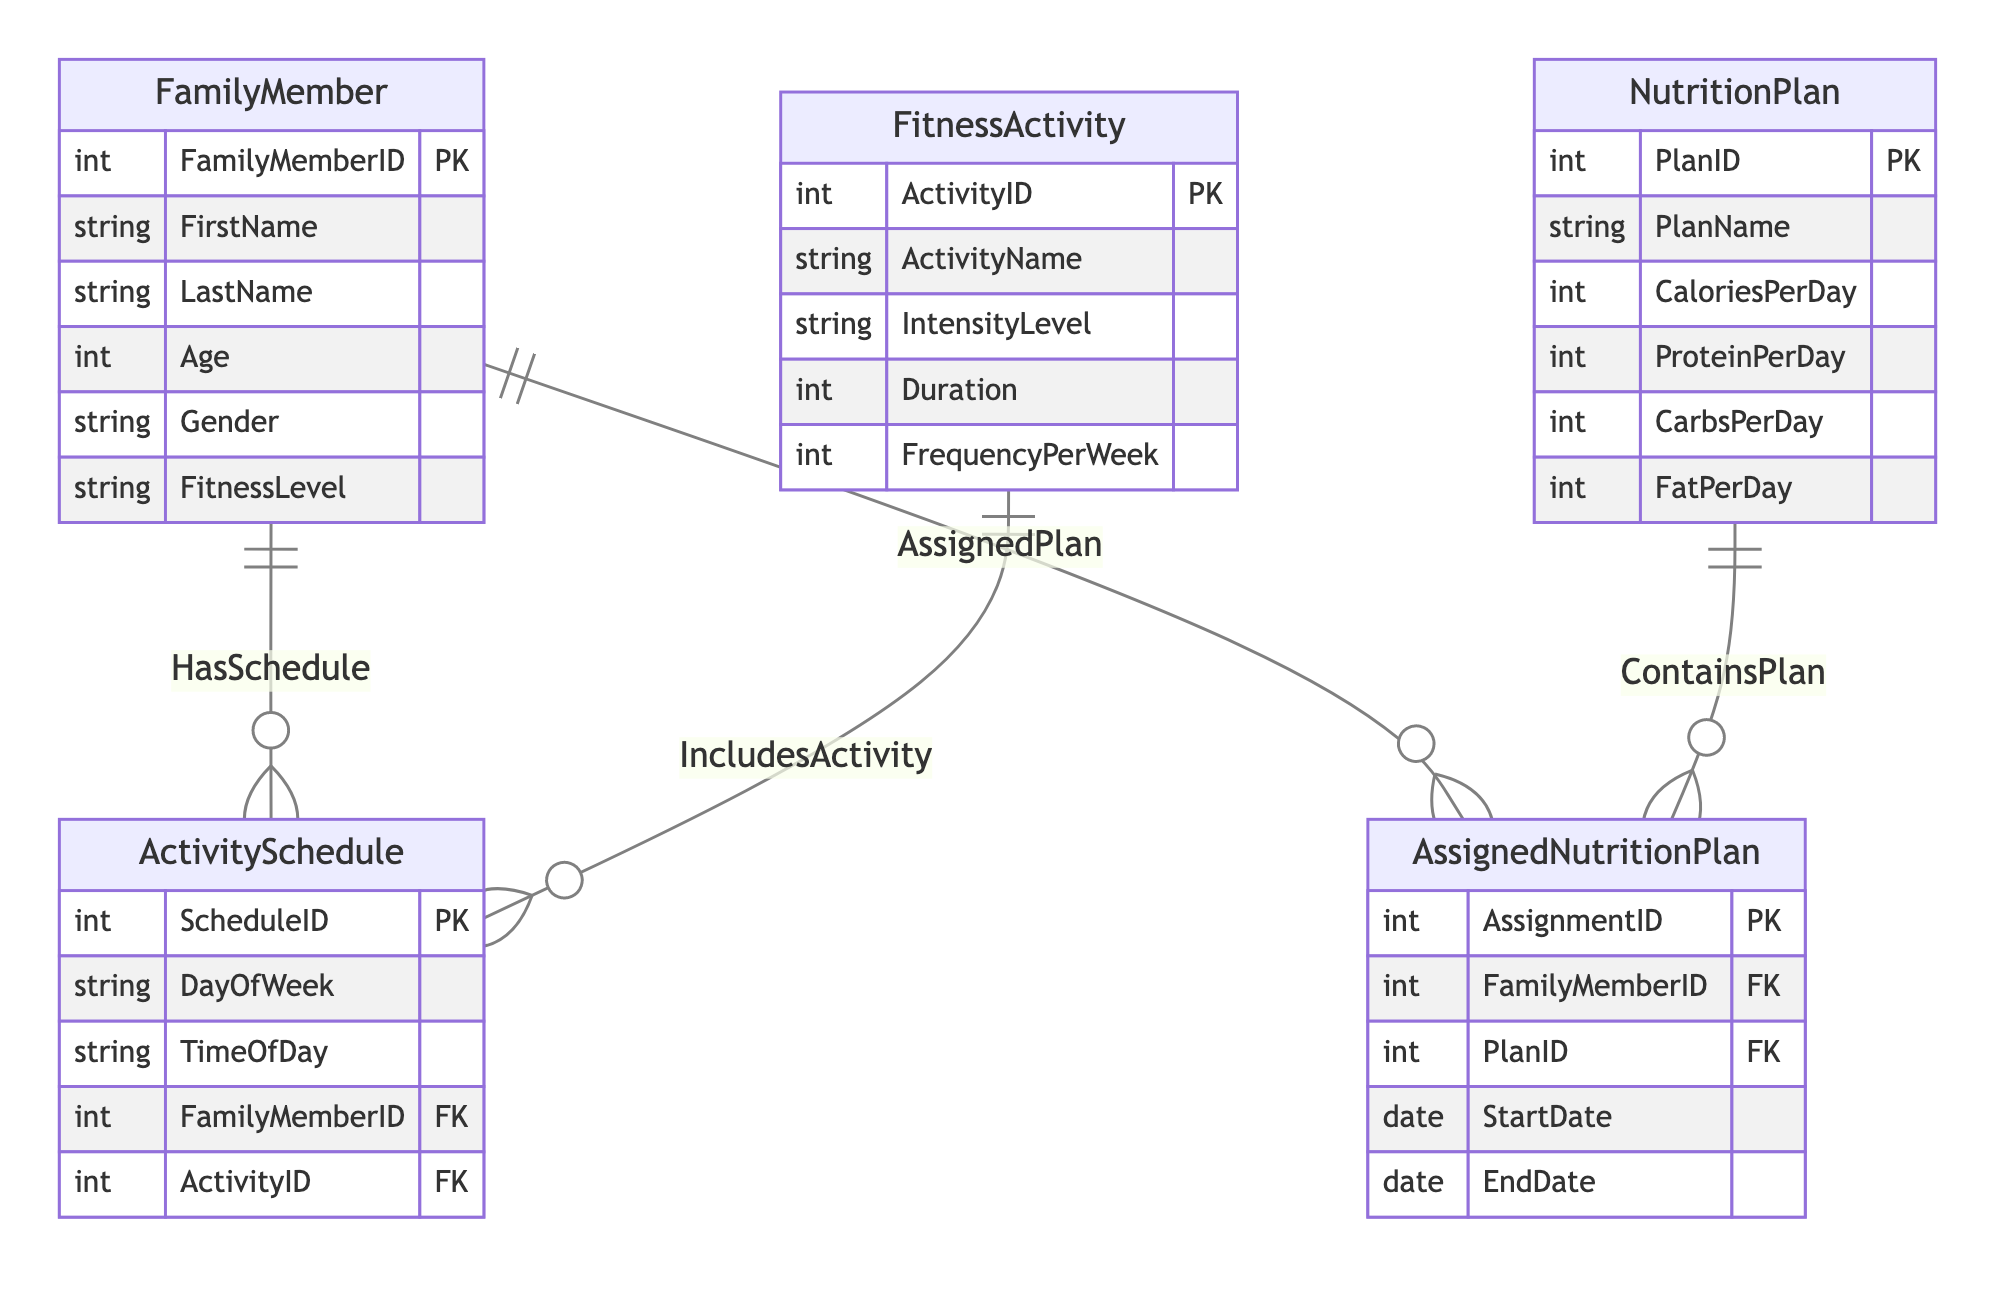What is the primary key of the FamilyMember entity? The primary key of the FamilyMember entity is FamilyMemberID, as indicated by the notation "PK" next to that attribute in the entity definition.
Answer: FamilyMemberID How many attributes does the FitnessActivity entity have? The FitnessActivity entity has five attributes listed: ActivityID, ActivityName, IntensityLevel, Duration, and FrequencyPerWeek. Thus, the count is five.
Answer: Five Which entity participates in the AssignedPlan relationship? The AssignedPlan relationship includes the FamilyMember and AssignedNutritionPlan entities, as described in the relationships section of the diagram.
Answer: FamilyMember, AssignedNutritionPlan How many foreign keys are present in the ActivitySchedule entity? The ActivitySchedule entity has two foreign keys: FamilyMemberID and ActivityID. This can be derived from the 'foreignKeys' section within the ActivitySchedule definition.
Answer: Two What type of relationship exists between FitnessActivity and ActivitySchedule? The relationship between FitnessActivity and ActivitySchedule is described as "1 to many," which indicates that one fitness activity can be assigned to many activity schedules.
Answer: 1 to many Which entity has a one-to-many relationship with NutritionPlan? The AssignedNutritionPlan entity exhibits a one-to-many relationship with NutritionPlan, shown in the relationships section labeled as "ContainsPlan."
Answer: AssignedNutritionPlan How many families can one AssignedNutritionPlan be assigned to? One AssignedNutritionPlan can be assigned to only one FamilyMember, as indicated by the foreign key FamilyMemberID in the AssignedNutritionPlan entity.
Answer: One What is the relationship type between FamilyMember and ActivitySchedule? The relationship between FamilyMember and ActivitySchedule is "1 to many," meaning that a single family member can have multiple scheduled activities.
Answer: 1 to many What attribute specifies the duration of a FitnessActivity? The attribute that specifies the duration of a FitnessActivity is Duration, clearly defined in the FitnessActivity entity's attribute list.
Answer: Duration 